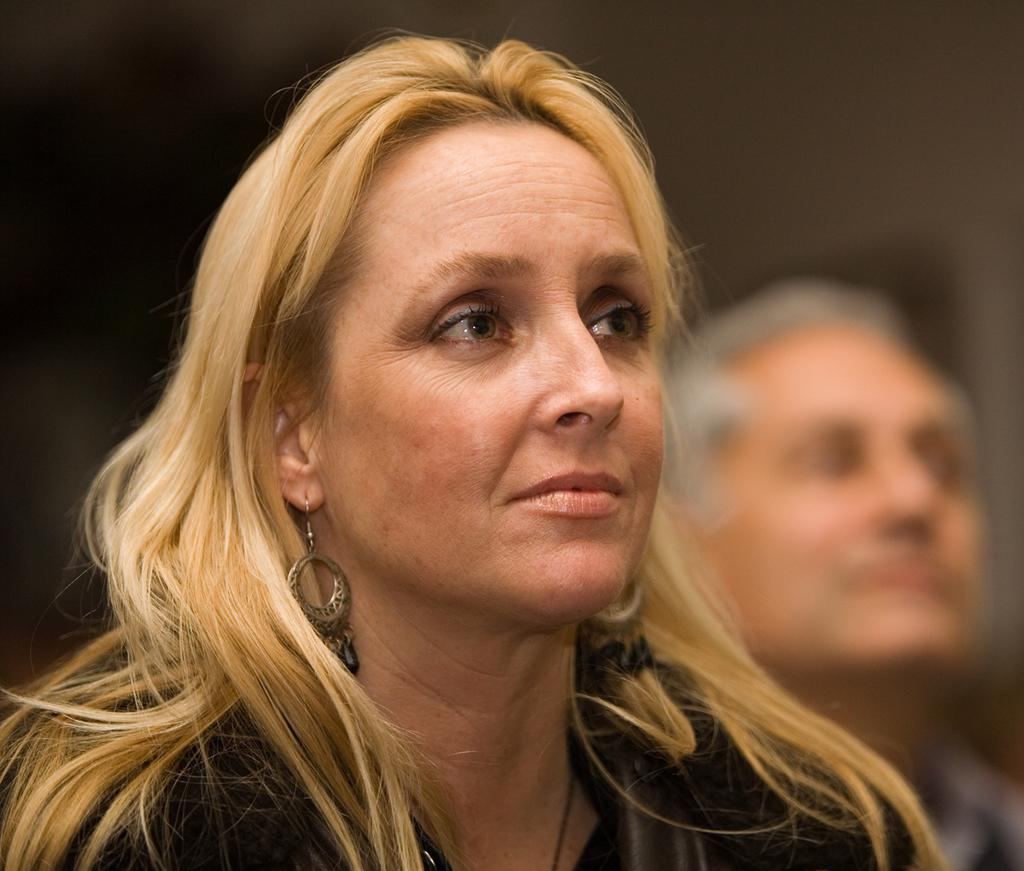Who is present in the image? There is a woman and a man in the image. What is the woman wearing in the image? The woman is wearing a brown jacket in the image. Can you describe the quality of the image? The image is blurry. What type of ink is being used by the woman in the image? There is no indication in the image that the woman is using any ink, so it cannot be determined from the picture. 